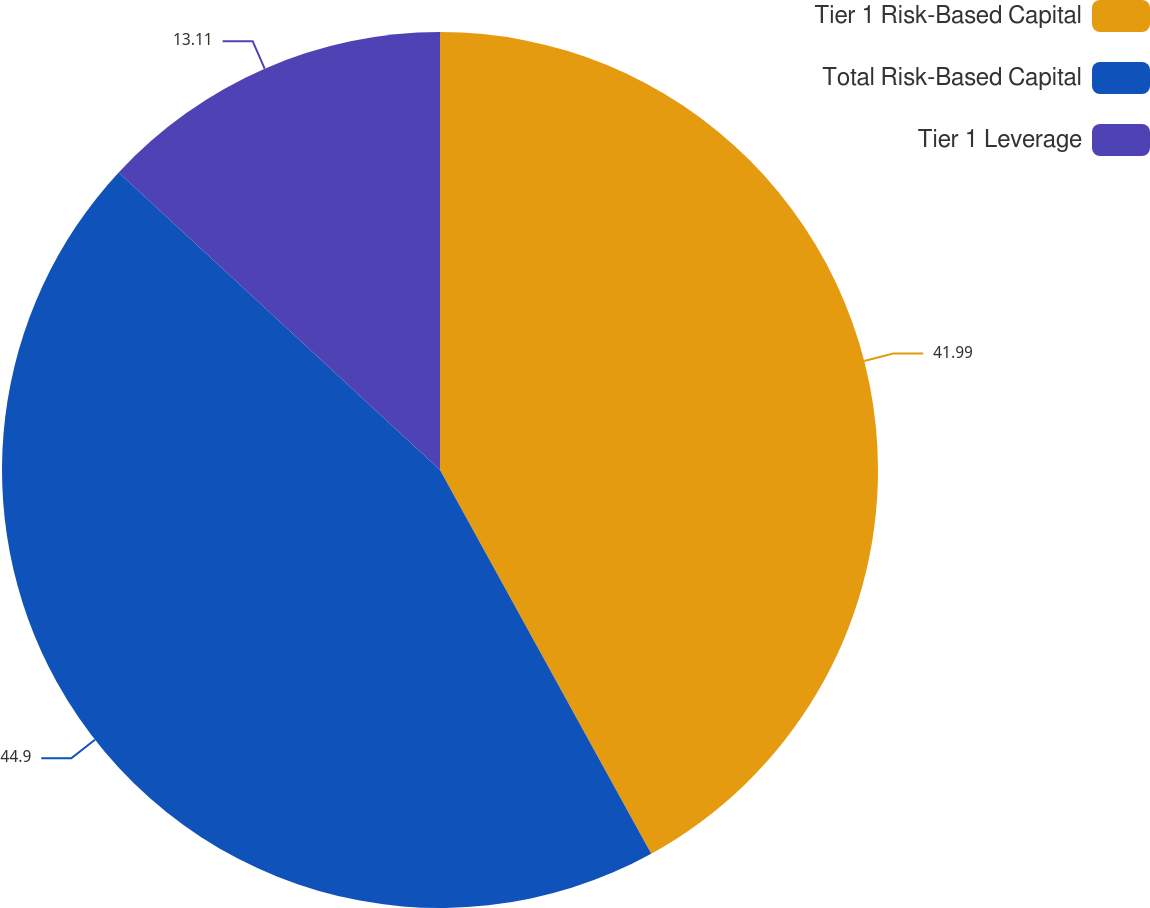Convert chart to OTSL. <chart><loc_0><loc_0><loc_500><loc_500><pie_chart><fcel>Tier 1 Risk-Based Capital<fcel>Total Risk-Based Capital<fcel>Tier 1 Leverage<nl><fcel>41.99%<fcel>44.9%<fcel>13.11%<nl></chart> 